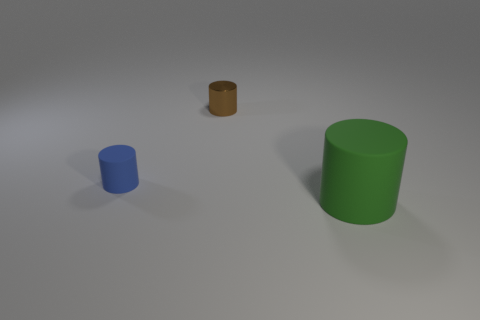How is the lighting in the scene affecting the appearance of the objects? The lighting in the scene is soft and diffused, casting gentle shadows to the right of the objects which indicates a light source to the left. This contributes to the objects having a slight gradient in color intensity, from brighter on the left to more shadowed on the right.  Given the way shadows are cast, can you deduce the time of day if this were outdoors? If this were an outdoor setting, the angle and length of the shadows suggesting a light source akin to the sun positioned to the left, could imply it's either morning or late afternoon when the sun is at a lower angle in the sky. However, without context or background, it's impossible to determine the precise time of day. 